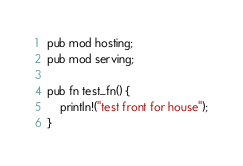<code> <loc_0><loc_0><loc_500><loc_500><_Rust_>pub mod hosting;
pub mod serving;

pub fn test_fn() {
    println!("test front for house");
}
</code> 